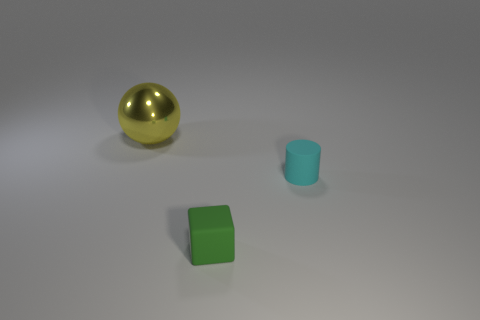Is there any other thing of the same color as the tiny matte cylinder?
Provide a short and direct response. No. Are the big yellow sphere and the small green cube made of the same material?
Offer a very short reply. No. Is the number of yellow shiny balls less than the number of gray shiny cubes?
Provide a short and direct response. No. The metal object has what color?
Ensure brevity in your answer.  Yellow. How many other objects are there of the same material as the small block?
Your answer should be very brief. 1. What number of yellow things are rubber cylinders or big metallic objects?
Provide a succinct answer. 1. How many things are spheres or things that are on the left side of the small green rubber cube?
Provide a succinct answer. 1. There is a thing that is on the left side of the small cyan rubber cylinder and in front of the yellow metallic ball; what material is it made of?
Ensure brevity in your answer.  Rubber. What is the small thing on the left side of the small cyan matte cylinder made of?
Your answer should be very brief. Rubber. What is the color of the block that is made of the same material as the cyan cylinder?
Ensure brevity in your answer.  Green. 